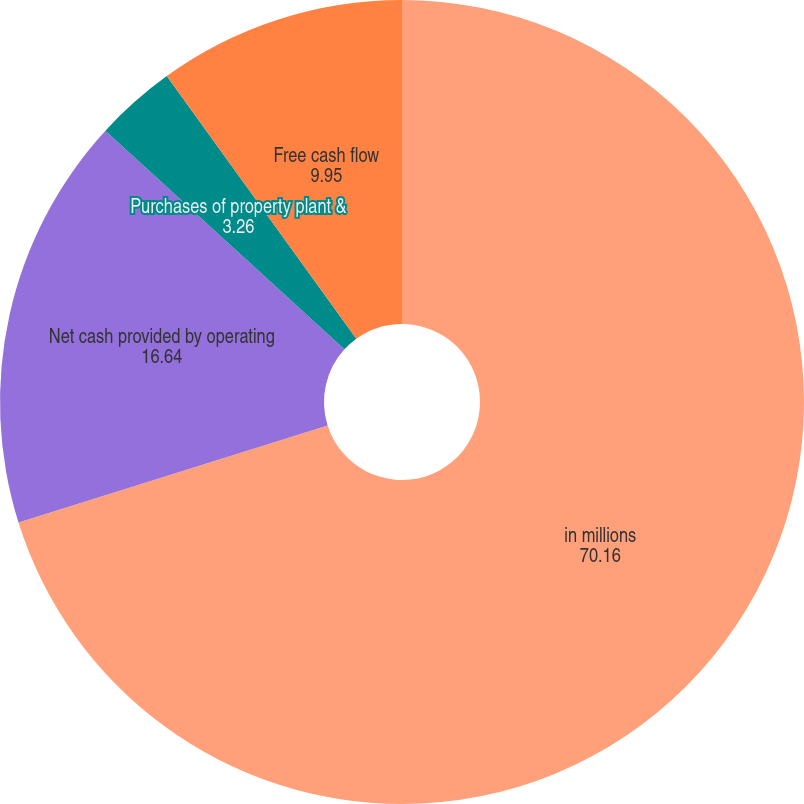Convert chart to OTSL. <chart><loc_0><loc_0><loc_500><loc_500><pie_chart><fcel>in millions<fcel>Net cash provided by operating<fcel>Purchases of property plant &<fcel>Free cash flow<nl><fcel>70.16%<fcel>16.64%<fcel>3.26%<fcel>9.95%<nl></chart> 